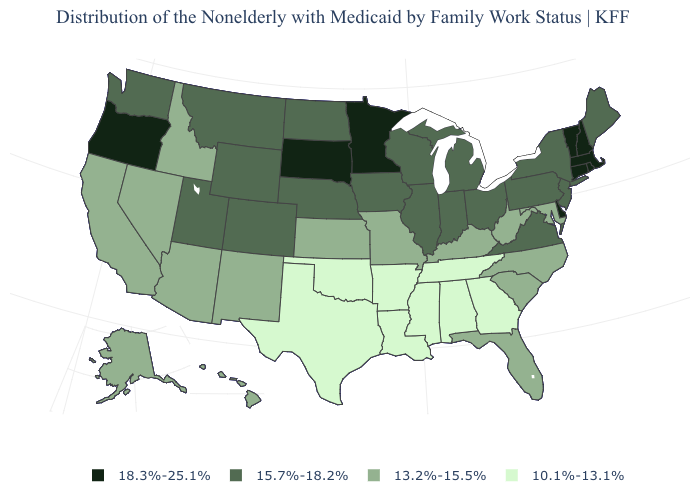Name the states that have a value in the range 10.1%-13.1%?
Be succinct. Alabama, Arkansas, Georgia, Louisiana, Mississippi, Oklahoma, Tennessee, Texas. Does the map have missing data?
Short answer required. No. Which states hav the highest value in the West?
Write a very short answer. Oregon. Does South Carolina have the same value as Alabama?
Keep it brief. No. Which states hav the highest value in the MidWest?
Short answer required. Minnesota, South Dakota. How many symbols are there in the legend?
Short answer required. 4. What is the lowest value in the South?
Write a very short answer. 10.1%-13.1%. Name the states that have a value in the range 10.1%-13.1%?
Answer briefly. Alabama, Arkansas, Georgia, Louisiana, Mississippi, Oklahoma, Tennessee, Texas. Name the states that have a value in the range 13.2%-15.5%?
Answer briefly. Alaska, Arizona, California, Florida, Hawaii, Idaho, Kansas, Kentucky, Maryland, Missouri, Nevada, New Mexico, North Carolina, South Carolina, West Virginia. Name the states that have a value in the range 18.3%-25.1%?
Answer briefly. Connecticut, Delaware, Massachusetts, Minnesota, New Hampshire, Oregon, Rhode Island, South Dakota, Vermont. Name the states that have a value in the range 15.7%-18.2%?
Concise answer only. Colorado, Illinois, Indiana, Iowa, Maine, Michigan, Montana, Nebraska, New Jersey, New York, North Dakota, Ohio, Pennsylvania, Utah, Virginia, Washington, Wisconsin, Wyoming. Among the states that border Louisiana , which have the highest value?
Give a very brief answer. Arkansas, Mississippi, Texas. Among the states that border Texas , which have the lowest value?
Quick response, please. Arkansas, Louisiana, Oklahoma. What is the value of Pennsylvania?
Give a very brief answer. 15.7%-18.2%. Does Rhode Island have a higher value than Massachusetts?
Keep it brief. No. 